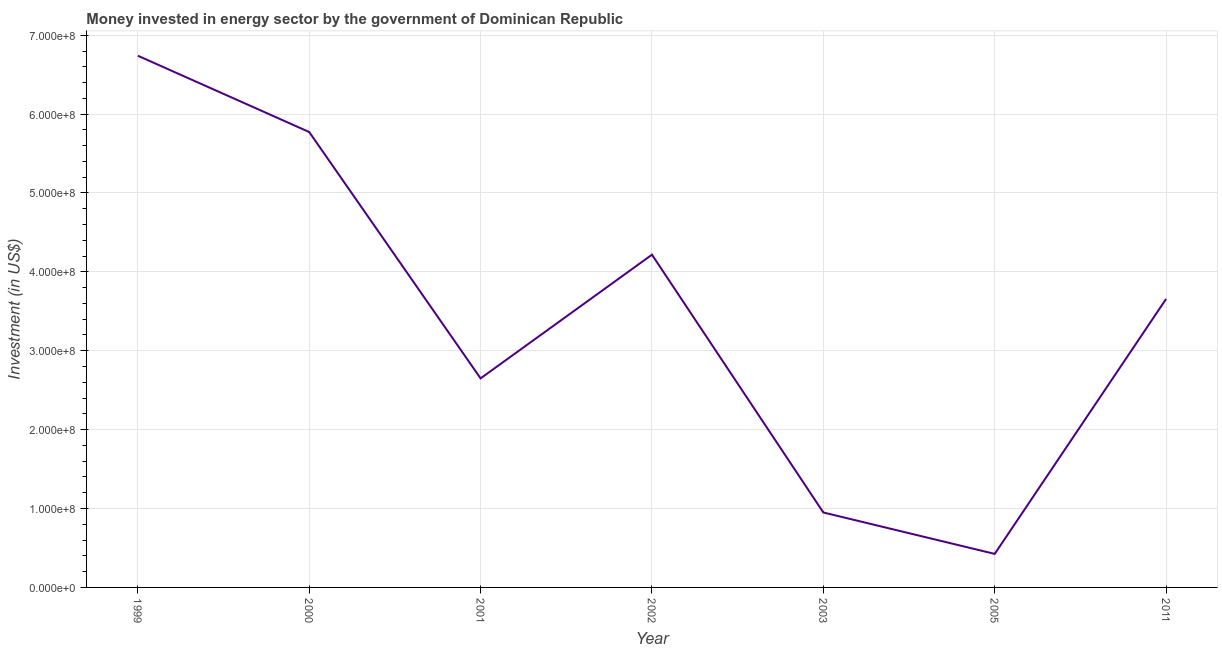What is the investment in energy in 2011?
Keep it short and to the point. 3.66e+08. Across all years, what is the maximum investment in energy?
Provide a short and direct response. 6.74e+08. Across all years, what is the minimum investment in energy?
Your answer should be compact. 4.25e+07. What is the sum of the investment in energy?
Ensure brevity in your answer.  2.44e+09. What is the difference between the investment in energy in 1999 and 2000?
Provide a short and direct response. 9.67e+07. What is the average investment in energy per year?
Your response must be concise. 3.49e+08. What is the median investment in energy?
Give a very brief answer. 3.66e+08. In how many years, is the investment in energy greater than 660000000 US$?
Make the answer very short. 1. Do a majority of the years between 2001 and 1999 (inclusive) have investment in energy greater than 520000000 US$?
Your answer should be very brief. No. What is the ratio of the investment in energy in 2000 to that in 2001?
Provide a succinct answer. 2.18. What is the difference between the highest and the second highest investment in energy?
Your answer should be very brief. 9.67e+07. Is the sum of the investment in energy in 1999 and 2001 greater than the maximum investment in energy across all years?
Your response must be concise. Yes. What is the difference between the highest and the lowest investment in energy?
Provide a short and direct response. 6.32e+08. In how many years, is the investment in energy greater than the average investment in energy taken over all years?
Your response must be concise. 4. Does the investment in energy monotonically increase over the years?
Offer a very short reply. No. How many years are there in the graph?
Provide a succinct answer. 7. Does the graph contain grids?
Provide a short and direct response. Yes. What is the title of the graph?
Offer a very short reply. Money invested in energy sector by the government of Dominican Republic. What is the label or title of the X-axis?
Your response must be concise. Year. What is the label or title of the Y-axis?
Make the answer very short. Investment (in US$). What is the Investment (in US$) of 1999?
Give a very brief answer. 6.74e+08. What is the Investment (in US$) in 2000?
Your answer should be very brief. 5.77e+08. What is the Investment (in US$) in 2001?
Give a very brief answer. 2.65e+08. What is the Investment (in US$) in 2002?
Offer a very short reply. 4.22e+08. What is the Investment (in US$) in 2003?
Offer a very short reply. 9.50e+07. What is the Investment (in US$) of 2005?
Provide a succinct answer. 4.25e+07. What is the Investment (in US$) in 2011?
Keep it short and to the point. 3.66e+08. What is the difference between the Investment (in US$) in 1999 and 2000?
Offer a terse response. 9.67e+07. What is the difference between the Investment (in US$) in 1999 and 2001?
Offer a very short reply. 4.09e+08. What is the difference between the Investment (in US$) in 1999 and 2002?
Your answer should be compact. 2.52e+08. What is the difference between the Investment (in US$) in 1999 and 2003?
Make the answer very short. 5.79e+08. What is the difference between the Investment (in US$) in 1999 and 2005?
Your answer should be compact. 6.32e+08. What is the difference between the Investment (in US$) in 1999 and 2011?
Give a very brief answer. 3.08e+08. What is the difference between the Investment (in US$) in 2000 and 2001?
Provide a short and direct response. 3.12e+08. What is the difference between the Investment (in US$) in 2000 and 2002?
Your answer should be very brief. 1.56e+08. What is the difference between the Investment (in US$) in 2000 and 2003?
Your answer should be compact. 4.82e+08. What is the difference between the Investment (in US$) in 2000 and 2005?
Your response must be concise. 5.35e+08. What is the difference between the Investment (in US$) in 2000 and 2011?
Your response must be concise. 2.12e+08. What is the difference between the Investment (in US$) in 2001 and 2002?
Make the answer very short. -1.57e+08. What is the difference between the Investment (in US$) in 2001 and 2003?
Provide a succinct answer. 1.70e+08. What is the difference between the Investment (in US$) in 2001 and 2005?
Offer a very short reply. 2.22e+08. What is the difference between the Investment (in US$) in 2001 and 2011?
Provide a succinct answer. -1.01e+08. What is the difference between the Investment (in US$) in 2002 and 2003?
Provide a succinct answer. 3.27e+08. What is the difference between the Investment (in US$) in 2002 and 2005?
Provide a succinct answer. 3.79e+08. What is the difference between the Investment (in US$) in 2002 and 2011?
Your response must be concise. 5.61e+07. What is the difference between the Investment (in US$) in 2003 and 2005?
Offer a very short reply. 5.25e+07. What is the difference between the Investment (in US$) in 2003 and 2011?
Give a very brief answer. -2.71e+08. What is the difference between the Investment (in US$) in 2005 and 2011?
Your answer should be very brief. -3.23e+08. What is the ratio of the Investment (in US$) in 1999 to that in 2000?
Your answer should be very brief. 1.17. What is the ratio of the Investment (in US$) in 1999 to that in 2001?
Your answer should be compact. 2.54. What is the ratio of the Investment (in US$) in 1999 to that in 2002?
Ensure brevity in your answer.  1.6. What is the ratio of the Investment (in US$) in 1999 to that in 2003?
Provide a succinct answer. 7.09. What is the ratio of the Investment (in US$) in 1999 to that in 2005?
Your answer should be very brief. 15.86. What is the ratio of the Investment (in US$) in 1999 to that in 2011?
Give a very brief answer. 1.84. What is the ratio of the Investment (in US$) in 2000 to that in 2001?
Your response must be concise. 2.18. What is the ratio of the Investment (in US$) in 2000 to that in 2002?
Your response must be concise. 1.37. What is the ratio of the Investment (in US$) in 2000 to that in 2003?
Your answer should be very brief. 6.08. What is the ratio of the Investment (in US$) in 2000 to that in 2005?
Offer a very short reply. 13.58. What is the ratio of the Investment (in US$) in 2000 to that in 2011?
Provide a succinct answer. 1.58. What is the ratio of the Investment (in US$) in 2001 to that in 2002?
Make the answer very short. 0.63. What is the ratio of the Investment (in US$) in 2001 to that in 2003?
Provide a succinct answer. 2.79. What is the ratio of the Investment (in US$) in 2001 to that in 2005?
Provide a succinct answer. 6.24. What is the ratio of the Investment (in US$) in 2001 to that in 2011?
Your answer should be compact. 0.72. What is the ratio of the Investment (in US$) in 2002 to that in 2003?
Offer a terse response. 4.44. What is the ratio of the Investment (in US$) in 2002 to that in 2005?
Your answer should be compact. 9.93. What is the ratio of the Investment (in US$) in 2002 to that in 2011?
Ensure brevity in your answer.  1.15. What is the ratio of the Investment (in US$) in 2003 to that in 2005?
Give a very brief answer. 2.23. What is the ratio of the Investment (in US$) in 2003 to that in 2011?
Keep it short and to the point. 0.26. What is the ratio of the Investment (in US$) in 2005 to that in 2011?
Offer a very short reply. 0.12. 